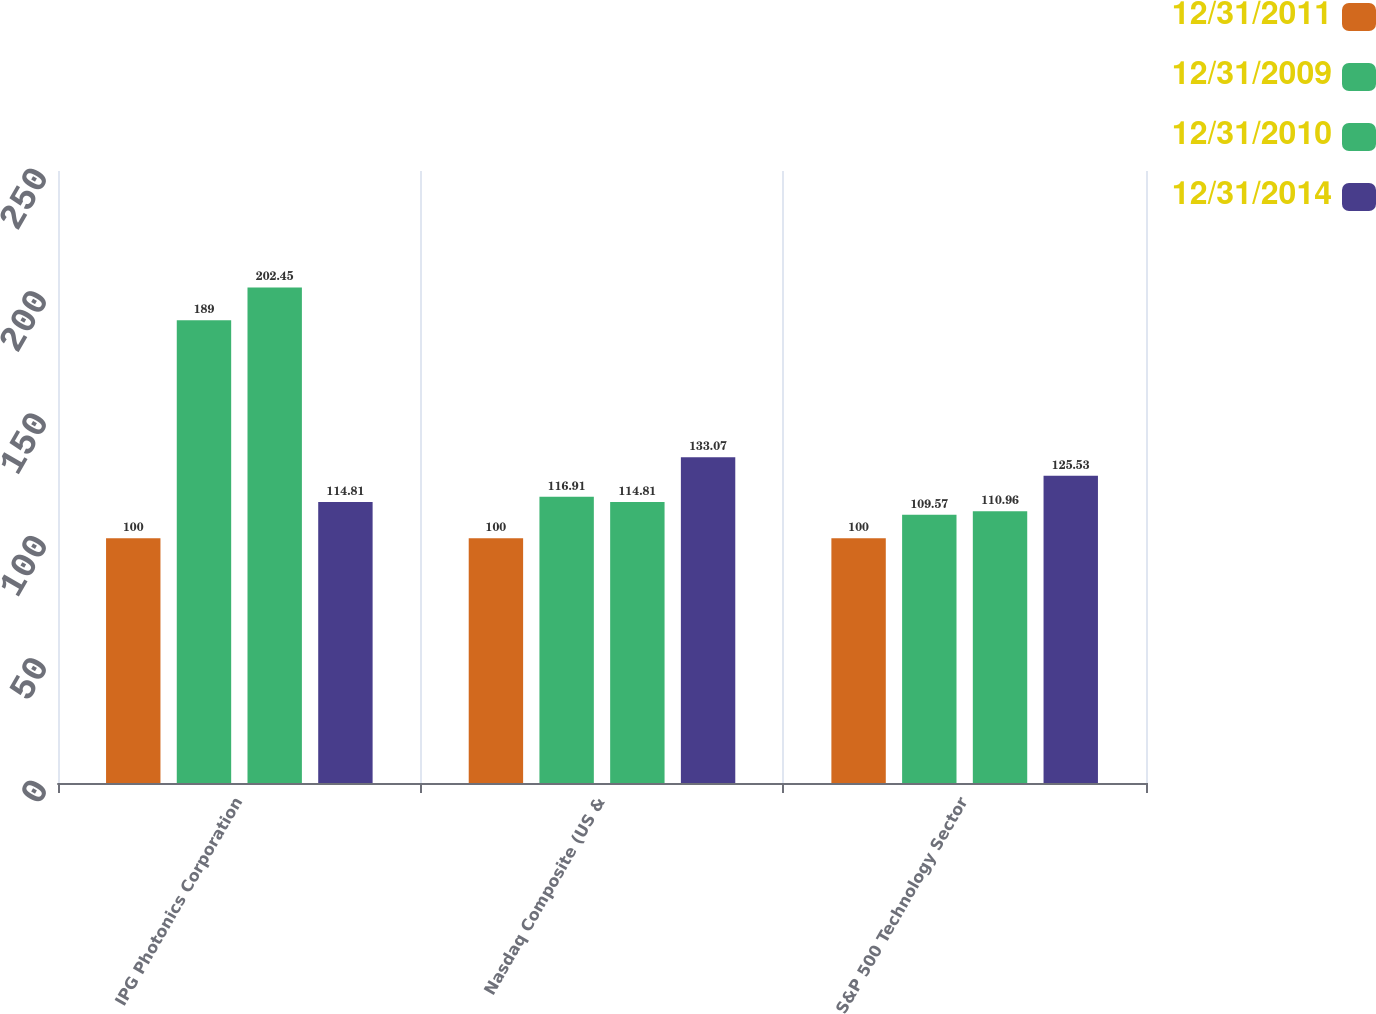<chart> <loc_0><loc_0><loc_500><loc_500><stacked_bar_chart><ecel><fcel>IPG Photonics Corporation<fcel>Nasdaq Composite (US &<fcel>S&P 500 Technology Sector<nl><fcel>12/31/2011<fcel>100<fcel>100<fcel>100<nl><fcel>12/31/2009<fcel>189<fcel>116.91<fcel>109.57<nl><fcel>12/31/2010<fcel>202.45<fcel>114.81<fcel>110.96<nl><fcel>12/31/2014<fcel>114.81<fcel>133.07<fcel>125.53<nl></chart> 